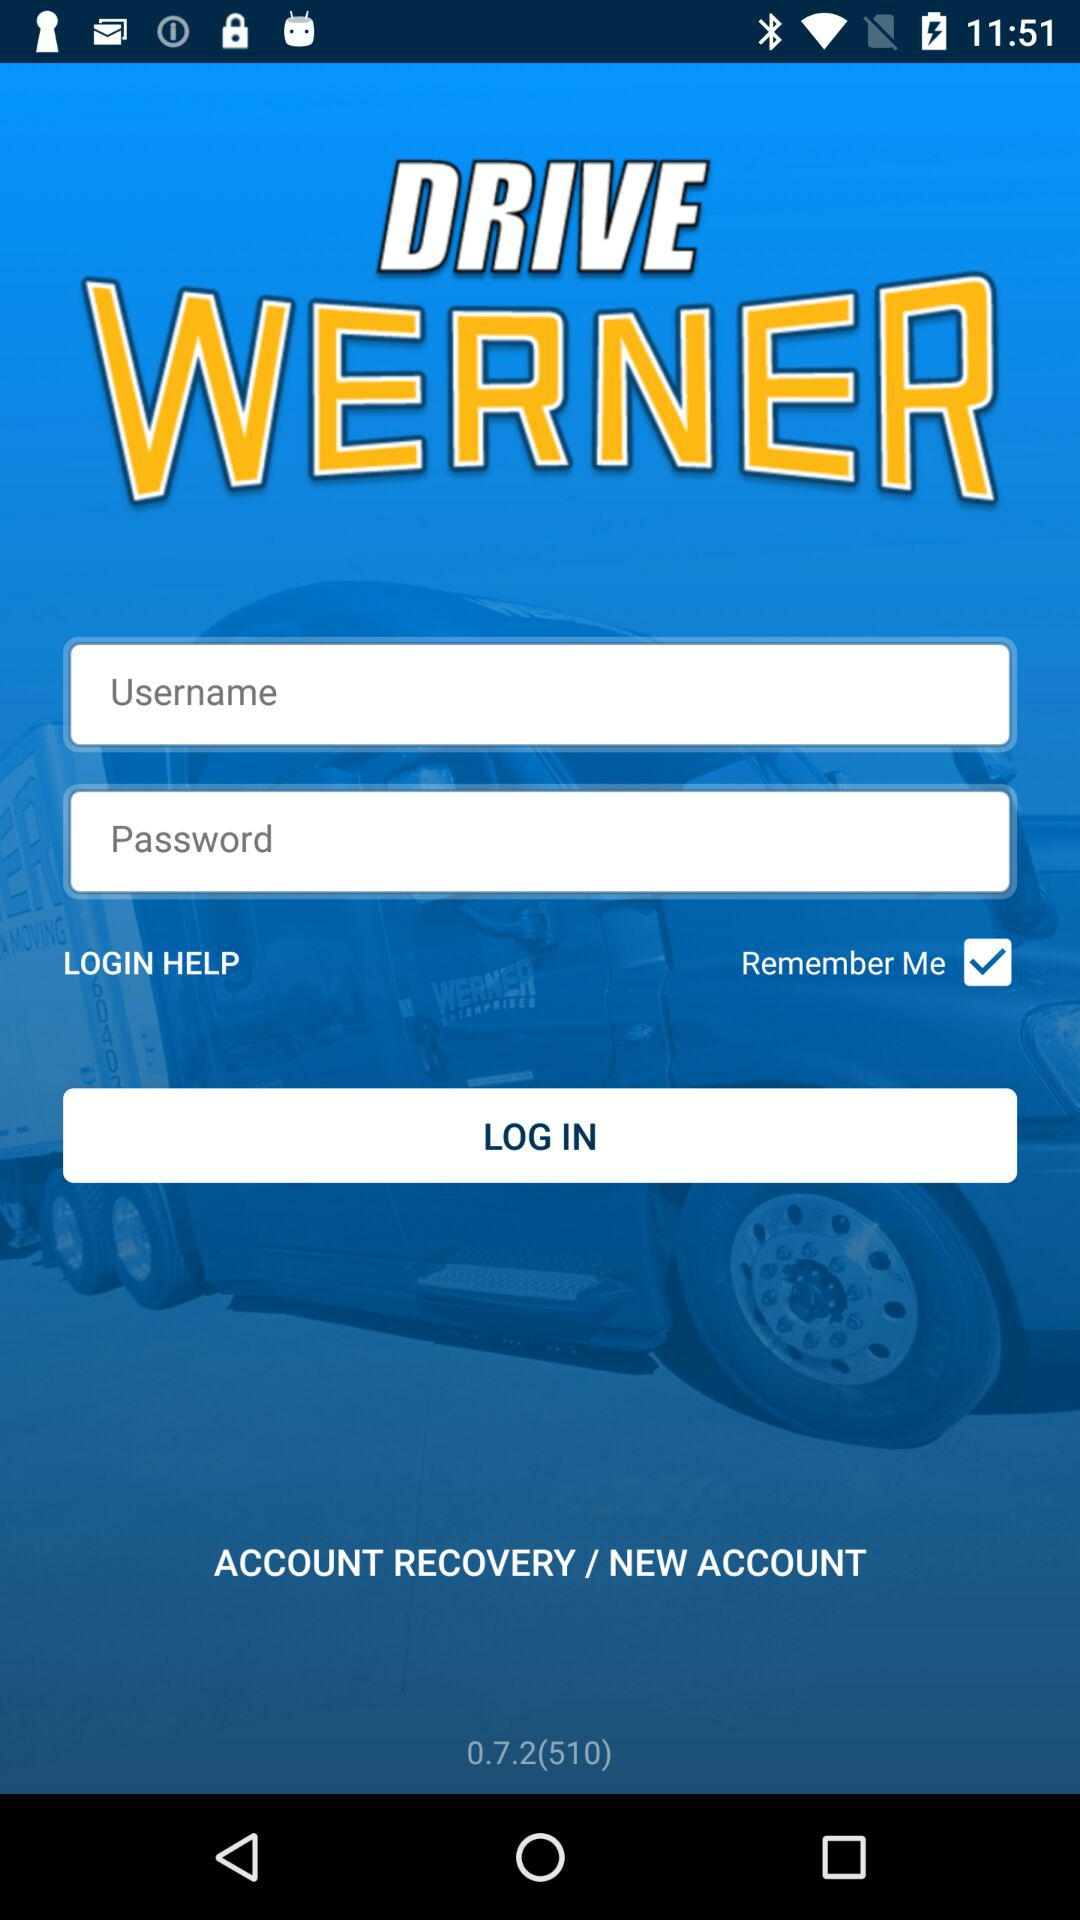How many more input fields are there than checkboxes?
Answer the question using a single word or phrase. 1 